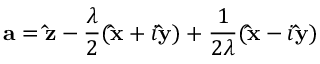<formula> <loc_0><loc_0><loc_500><loc_500>{ a } = { \hat { z } } - { \frac { \lambda } { 2 } } ( { \hat { x } } + i { \hat { y } } ) + { \frac { 1 } { 2 \lambda } } ( { \hat { x } } - i { \hat { y } } )</formula> 